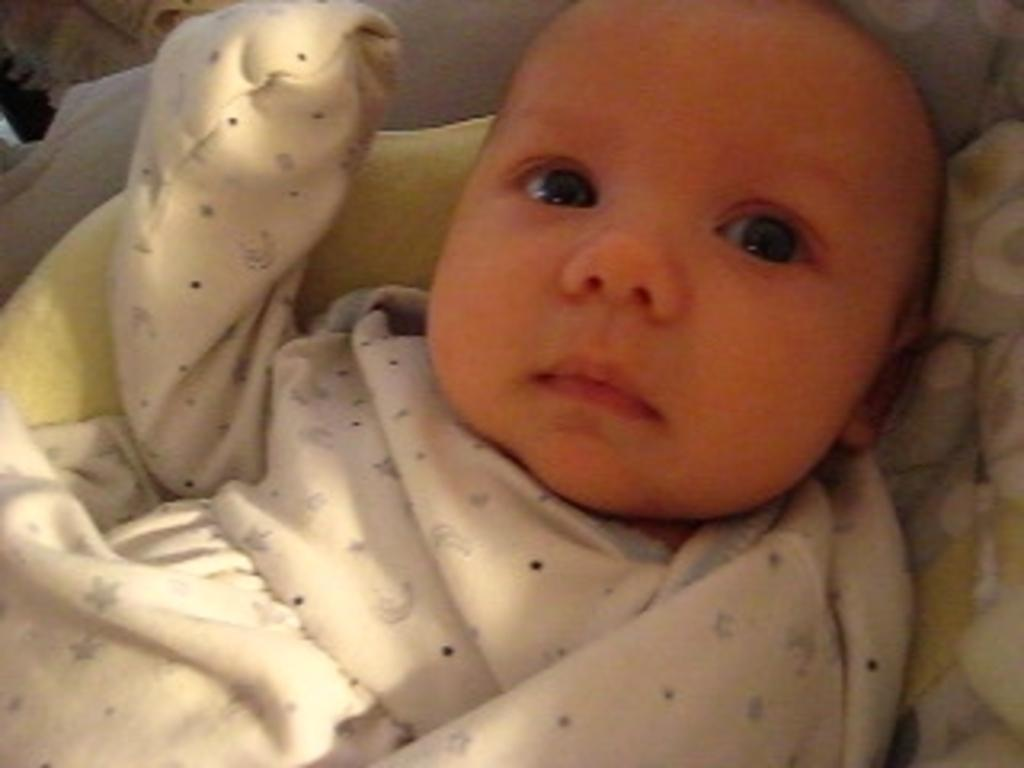What is the main subject of the image? The main subject of the image is a baby. What is the baby sitting in? The baby is sitting inside a cradle. What is the baby wearing? The baby is wearing a white dress. Is the baby wearing a cap while driving a tractor in the image? There is no cap, driving, or tractor present in the image. The baby is simply sitting inside a cradle while wearing a white dress. 